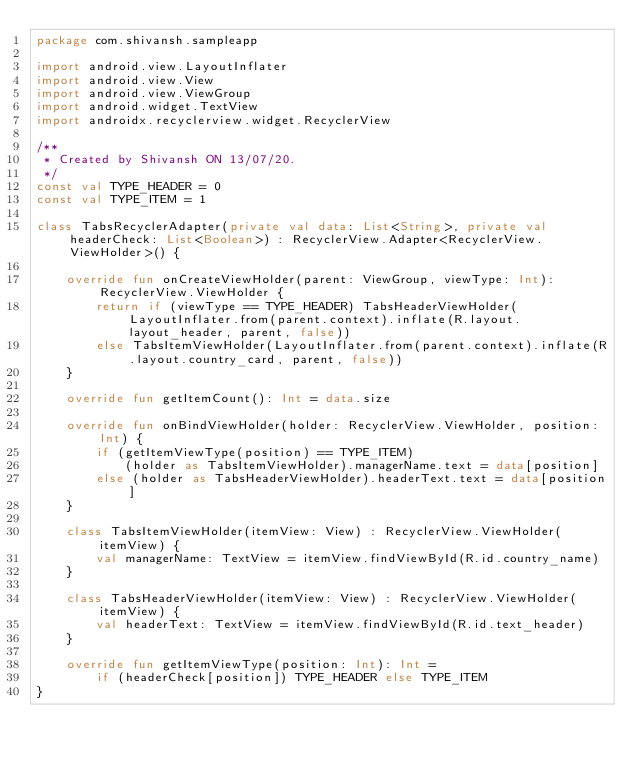Convert code to text. <code><loc_0><loc_0><loc_500><loc_500><_Kotlin_>package com.shivansh.sampleapp

import android.view.LayoutInflater
import android.view.View
import android.view.ViewGroup
import android.widget.TextView
import androidx.recyclerview.widget.RecyclerView

/**
 * Created by Shivansh ON 13/07/20.
 */
const val TYPE_HEADER = 0
const val TYPE_ITEM = 1

class TabsRecyclerAdapter(private val data: List<String>, private val headerCheck: List<Boolean>) : RecyclerView.Adapter<RecyclerView.ViewHolder>() {

    override fun onCreateViewHolder(parent: ViewGroup, viewType: Int): RecyclerView.ViewHolder {
        return if (viewType == TYPE_HEADER) TabsHeaderViewHolder(LayoutInflater.from(parent.context).inflate(R.layout.layout_header, parent, false))
        else TabsItemViewHolder(LayoutInflater.from(parent.context).inflate(R.layout.country_card, parent, false))
    }

    override fun getItemCount(): Int = data.size

    override fun onBindViewHolder(holder: RecyclerView.ViewHolder, position: Int) {
        if (getItemViewType(position) == TYPE_ITEM)
            (holder as TabsItemViewHolder).managerName.text = data[position]
        else (holder as TabsHeaderViewHolder).headerText.text = data[position]
    }

    class TabsItemViewHolder(itemView: View) : RecyclerView.ViewHolder(itemView) {
        val managerName: TextView = itemView.findViewById(R.id.country_name)
    }

    class TabsHeaderViewHolder(itemView: View) : RecyclerView.ViewHolder(itemView) {
        val headerText: TextView = itemView.findViewById(R.id.text_header)
    }

    override fun getItemViewType(position: Int): Int =
        if (headerCheck[position]) TYPE_HEADER else TYPE_ITEM
}
</code> 